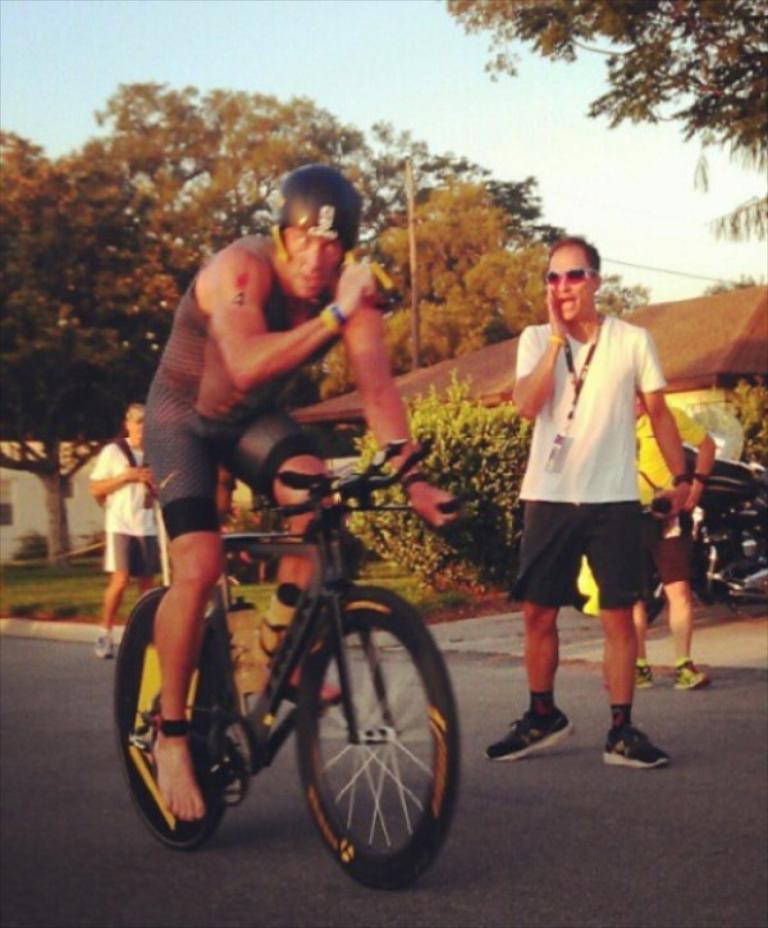Can you describe this image briefly? In image I can see a group of people among them, a man is riding a bicycle on the road. I can also see there are few trees and a house. 